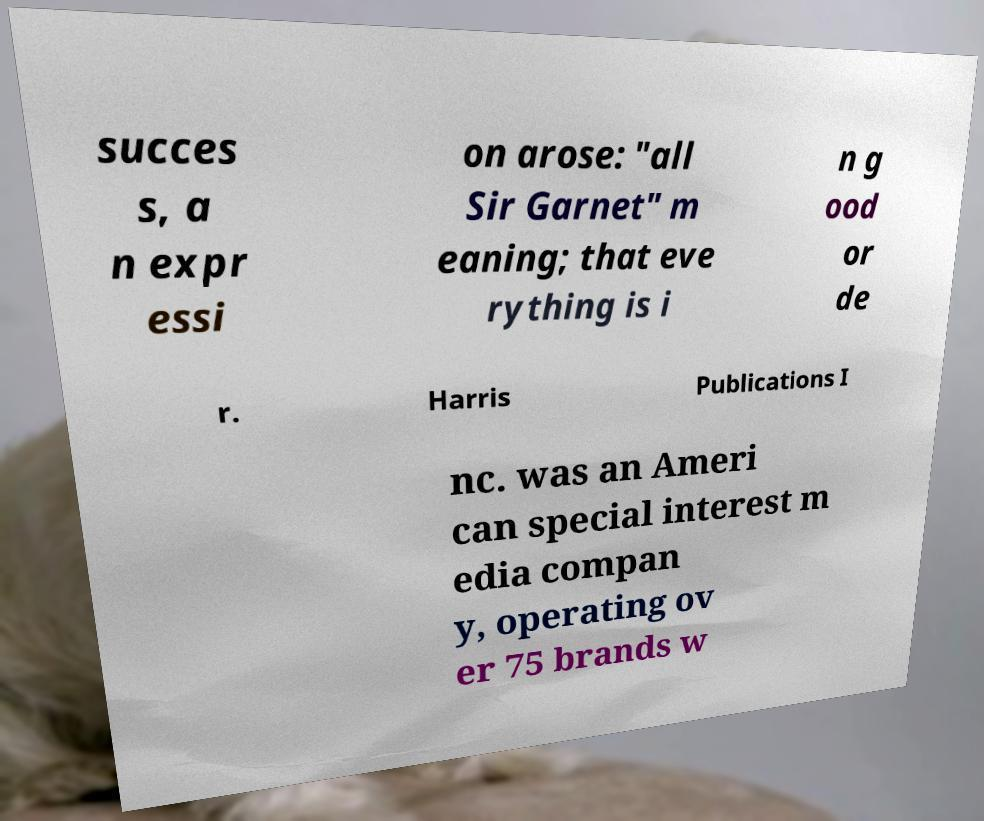Could you assist in decoding the text presented in this image and type it out clearly? succes s, a n expr essi on arose: "all Sir Garnet" m eaning; that eve rything is i n g ood or de r. Harris Publications I nc. was an Ameri can special interest m edia compan y, operating ov er 75 brands w 